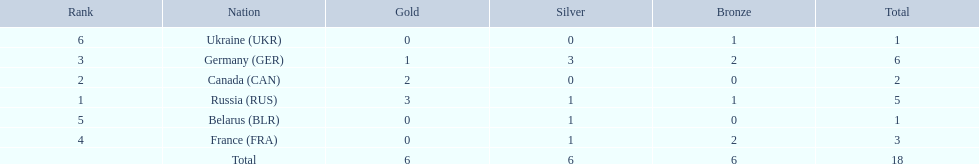What were all the countries that won biathlon medals? Russia (RUS), Canada (CAN), Germany (GER), France (FRA), Belarus (BLR), Ukraine (UKR). What were their medal counts? 5, 2, 6, 3, 1, 1. Of these, which is the largest number of medals? 6. Which country won this number of medals? Germany (GER). 